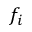Convert formula to latex. <formula><loc_0><loc_0><loc_500><loc_500>f _ { i }</formula> 